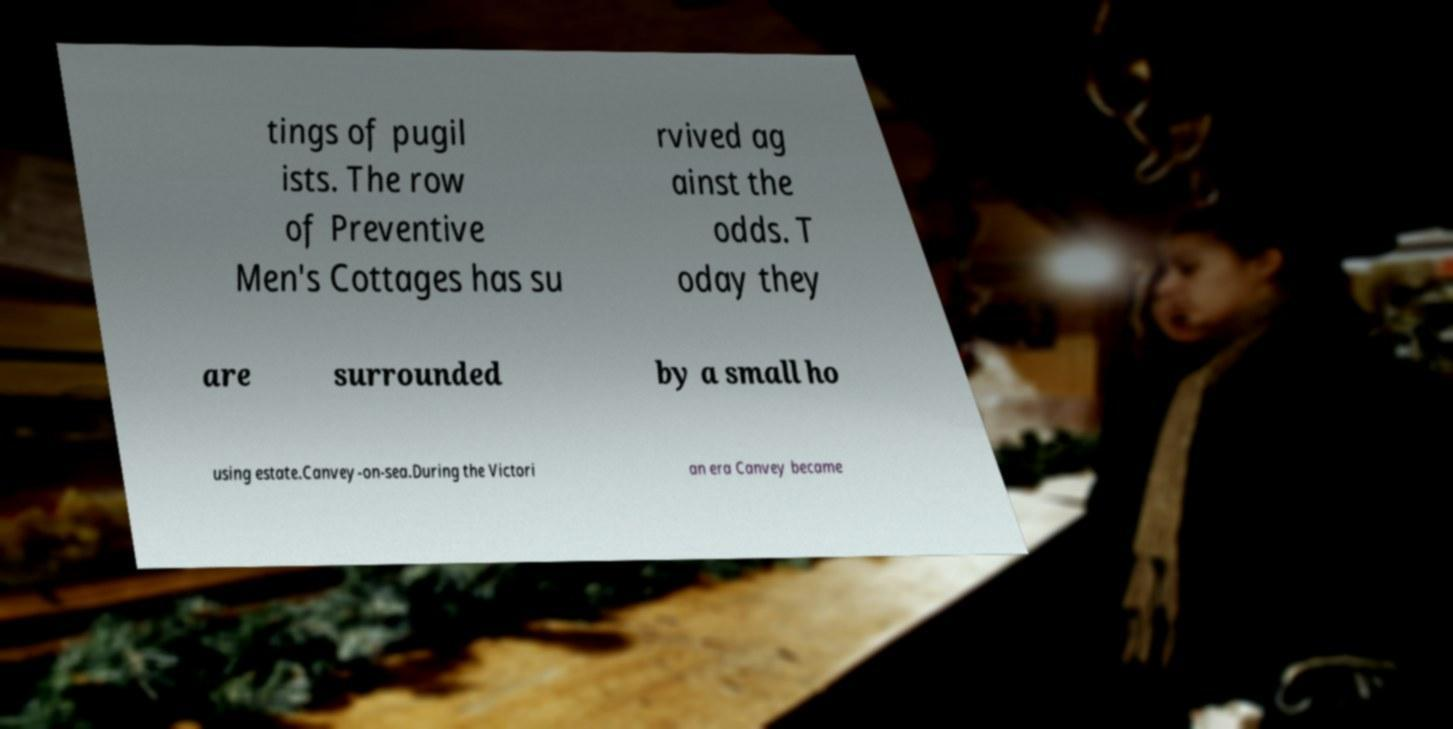For documentation purposes, I need the text within this image transcribed. Could you provide that? tings of pugil ists. The row of Preventive Men's Cottages has su rvived ag ainst the odds. T oday they are surrounded by a small ho using estate.Canvey-on-sea.During the Victori an era Canvey became 